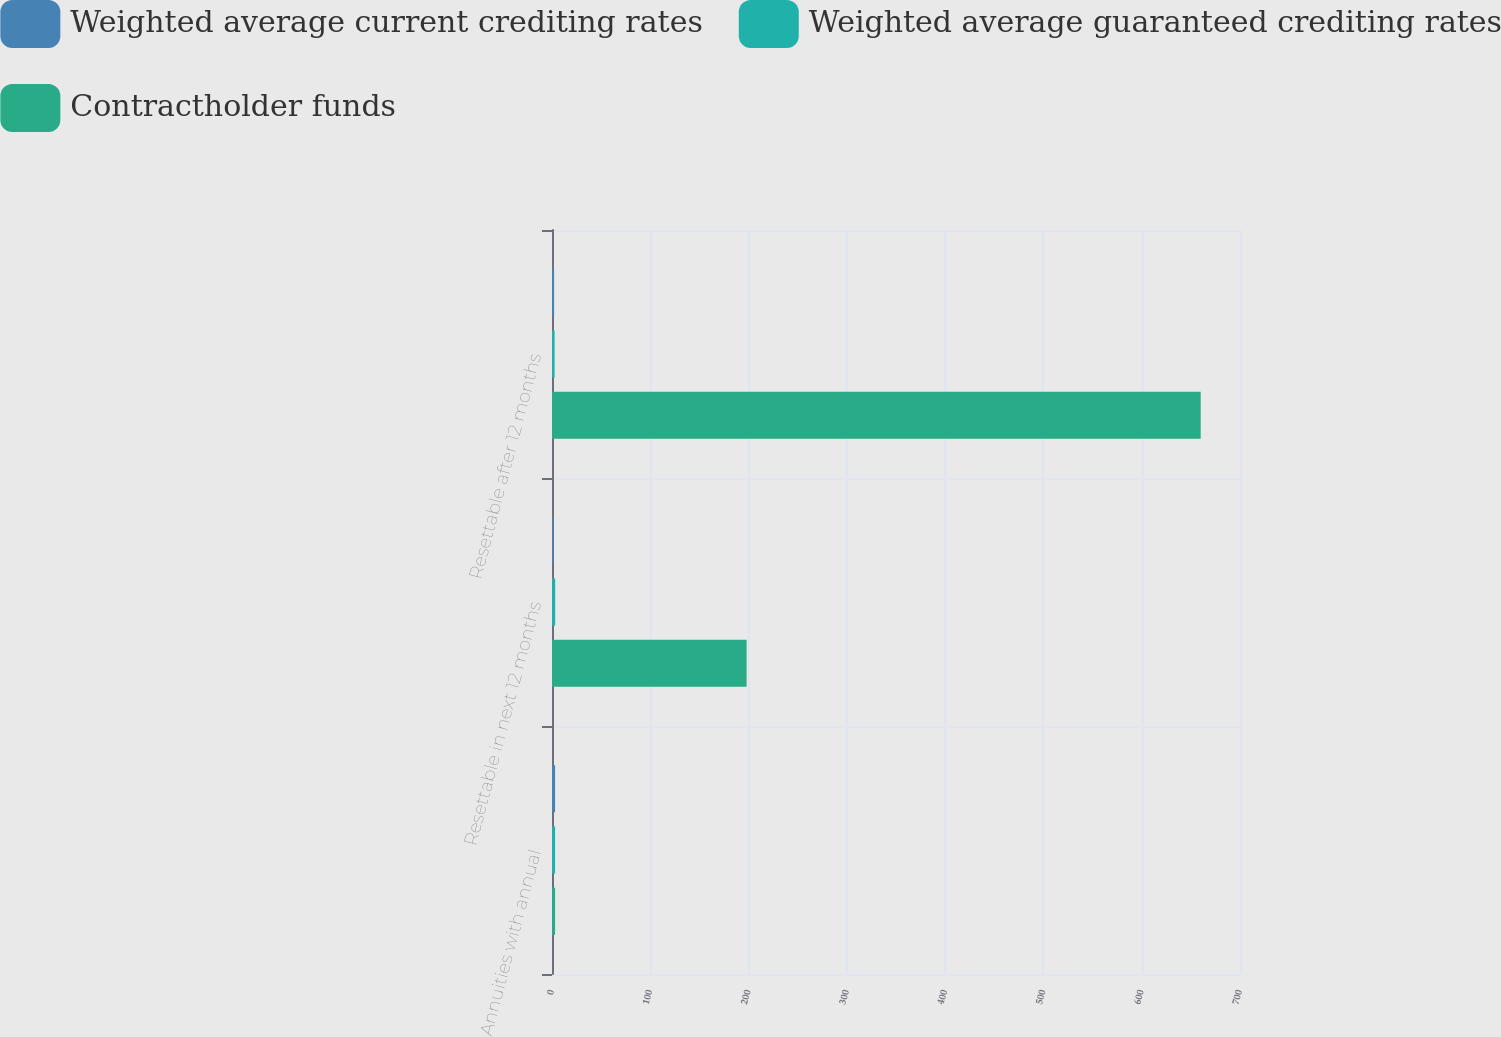Convert chart to OTSL. <chart><loc_0><loc_0><loc_500><loc_500><stacked_bar_chart><ecel><fcel>Annuities with annual<fcel>Resettable in next 12 months<fcel>Resettable after 12 months<nl><fcel>Weighted average current crediting rates<fcel>3.14<fcel>1.27<fcel>2.14<nl><fcel>Weighted average guaranteed crediting rates<fcel>3.14<fcel>3.23<fcel>2.67<nl><fcel>Contractholder funds<fcel>3.14<fcel>198<fcel>660<nl></chart> 